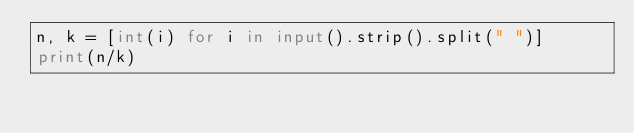<code> <loc_0><loc_0><loc_500><loc_500><_Python_>n, k = [int(i) for i in input().strip().split(" ")]
print(n/k)
</code> 